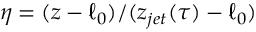<formula> <loc_0><loc_0><loc_500><loc_500>\eta = ( z - \ell _ { 0 } ) / ( z _ { j e t } ( \tau ) - \ell _ { 0 } )</formula> 